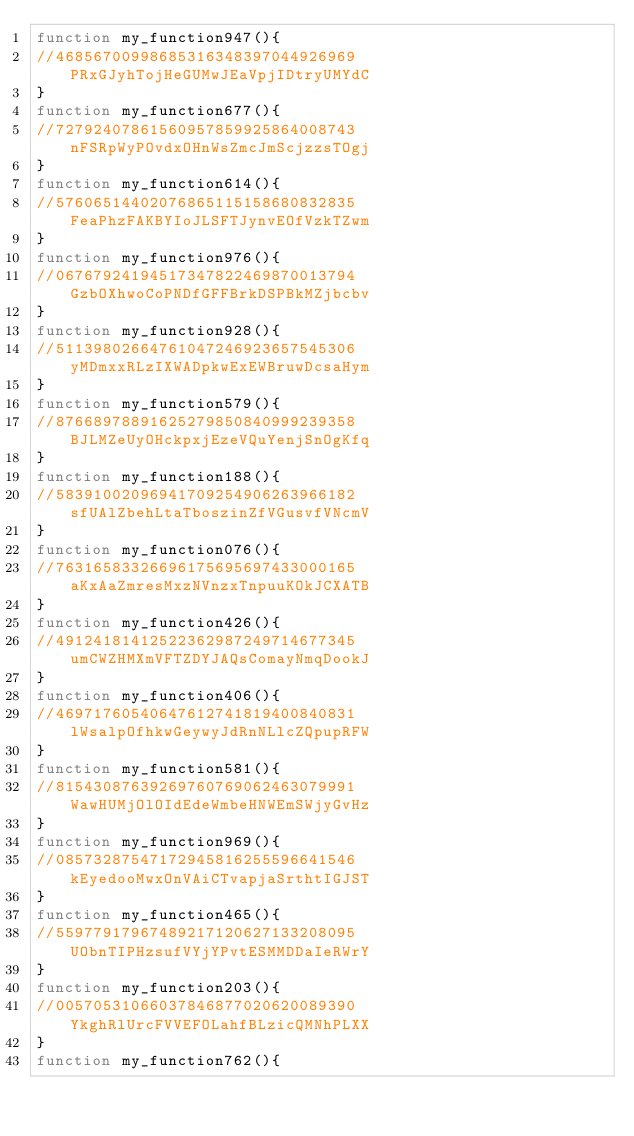Convert code to text. <code><loc_0><loc_0><loc_500><loc_500><_JavaScript_>function my_function947(){ 
//46856700998685316348397044926969PRxGJyhTojHeGUMwJEaVpjIDtryUMYdC
}
function my_function677(){ 
//72792407861560957859925864008743nFSRpWyPOvdxOHnWsZmcJmScjzzsTOgj
}
function my_function614(){ 
//57606514402076865115158680832835FeaPhzFAKBYIoJLSFTJynvEOfVzkTZwm
}
function my_function976(){ 
//06767924194517347822469870013794GzbOXhwoCoPNDfGFFBrkDSPBkMZjbcbv
}
function my_function928(){ 
//51139802664761047246923657545306yMDmxxRLzIXWADpkwExEWBruwDcsaHym
}
function my_function579(){ 
//87668978891625279850840999239358BJLMZeUyOHckpxjEzeVQuYenjSnOgKfq
}
function my_function188(){ 
//58391002096941709254906263966182sfUAlZbehLtaTboszinZfVGusvfVNcmV
}
function my_function076(){ 
//76316583326696175695697433000165aKxAaZmresMxzNVnzxTnpuuKOkJCXATB
}
function my_function426(){ 
//49124181412522362987249714677345umCWZHMXmVFTZDYJAQsComayNmqDookJ
}
function my_function406(){ 
//46971760540647612741819400840831lWsalpOfhkwGeywyJdRnNLlcZQpupRFW
}
function my_function581(){ 
//81543087639269760769062463079991WawHUMjOlOIdEdeWmbeHNWEmSWjyGvHz
}
function my_function969(){ 
//08573287547172945816255596641546kEyedooMwxOnVAiCTvapjaSrthtIGJST
}
function my_function465(){ 
//55977917967489217120627133208095UObnTIPHzsufVYjYPvtESMMDDaIeRWrY
}
function my_function203(){ 
//00570531066037846877020620089390YkghRlUrcFVVEFOLahfBLzicQMNhPLXX
}
function my_function762(){ </code> 